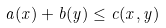<formula> <loc_0><loc_0><loc_500><loc_500>a ( x ) + b ( y ) \leq c ( x , y )</formula> 